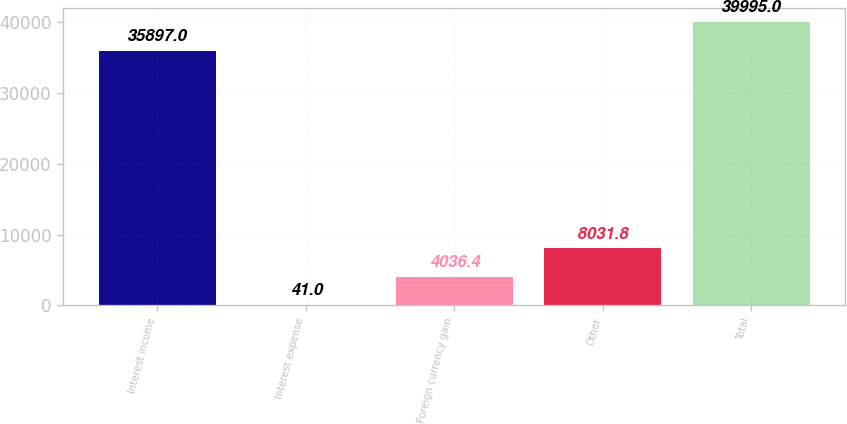<chart> <loc_0><loc_0><loc_500><loc_500><bar_chart><fcel>Interest income<fcel>Interest expense<fcel>Foreign currency gain<fcel>Other<fcel>Total<nl><fcel>35897<fcel>41<fcel>4036.4<fcel>8031.8<fcel>39995<nl></chart> 